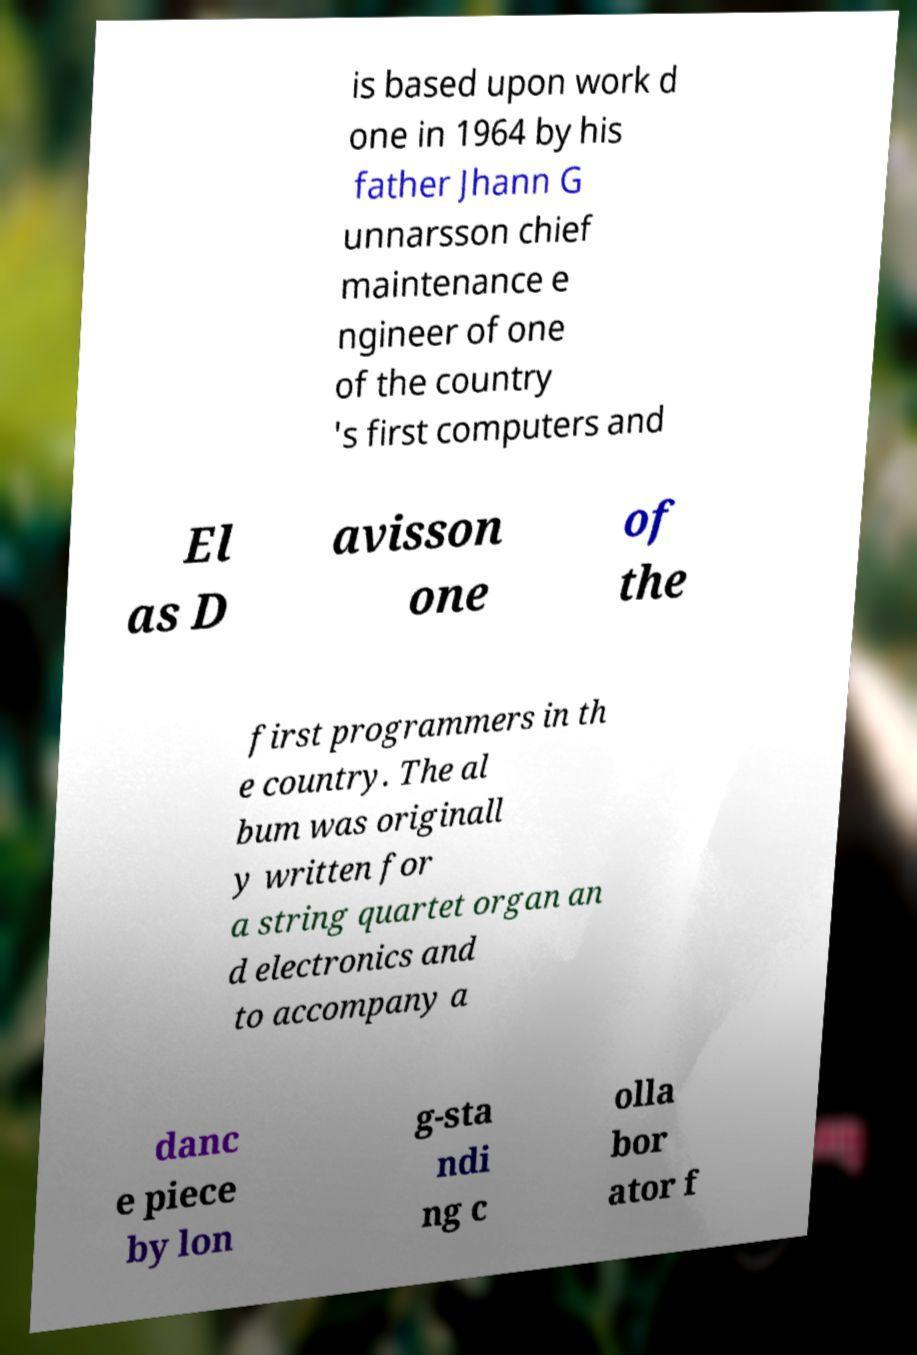Can you accurately transcribe the text from the provided image for me? is based upon work d one in 1964 by his father Jhann G unnarsson chief maintenance e ngineer of one of the country 's first computers and El as D avisson one of the first programmers in th e country. The al bum was originall y written for a string quartet organ an d electronics and to accompany a danc e piece by lon g-sta ndi ng c olla bor ator f 